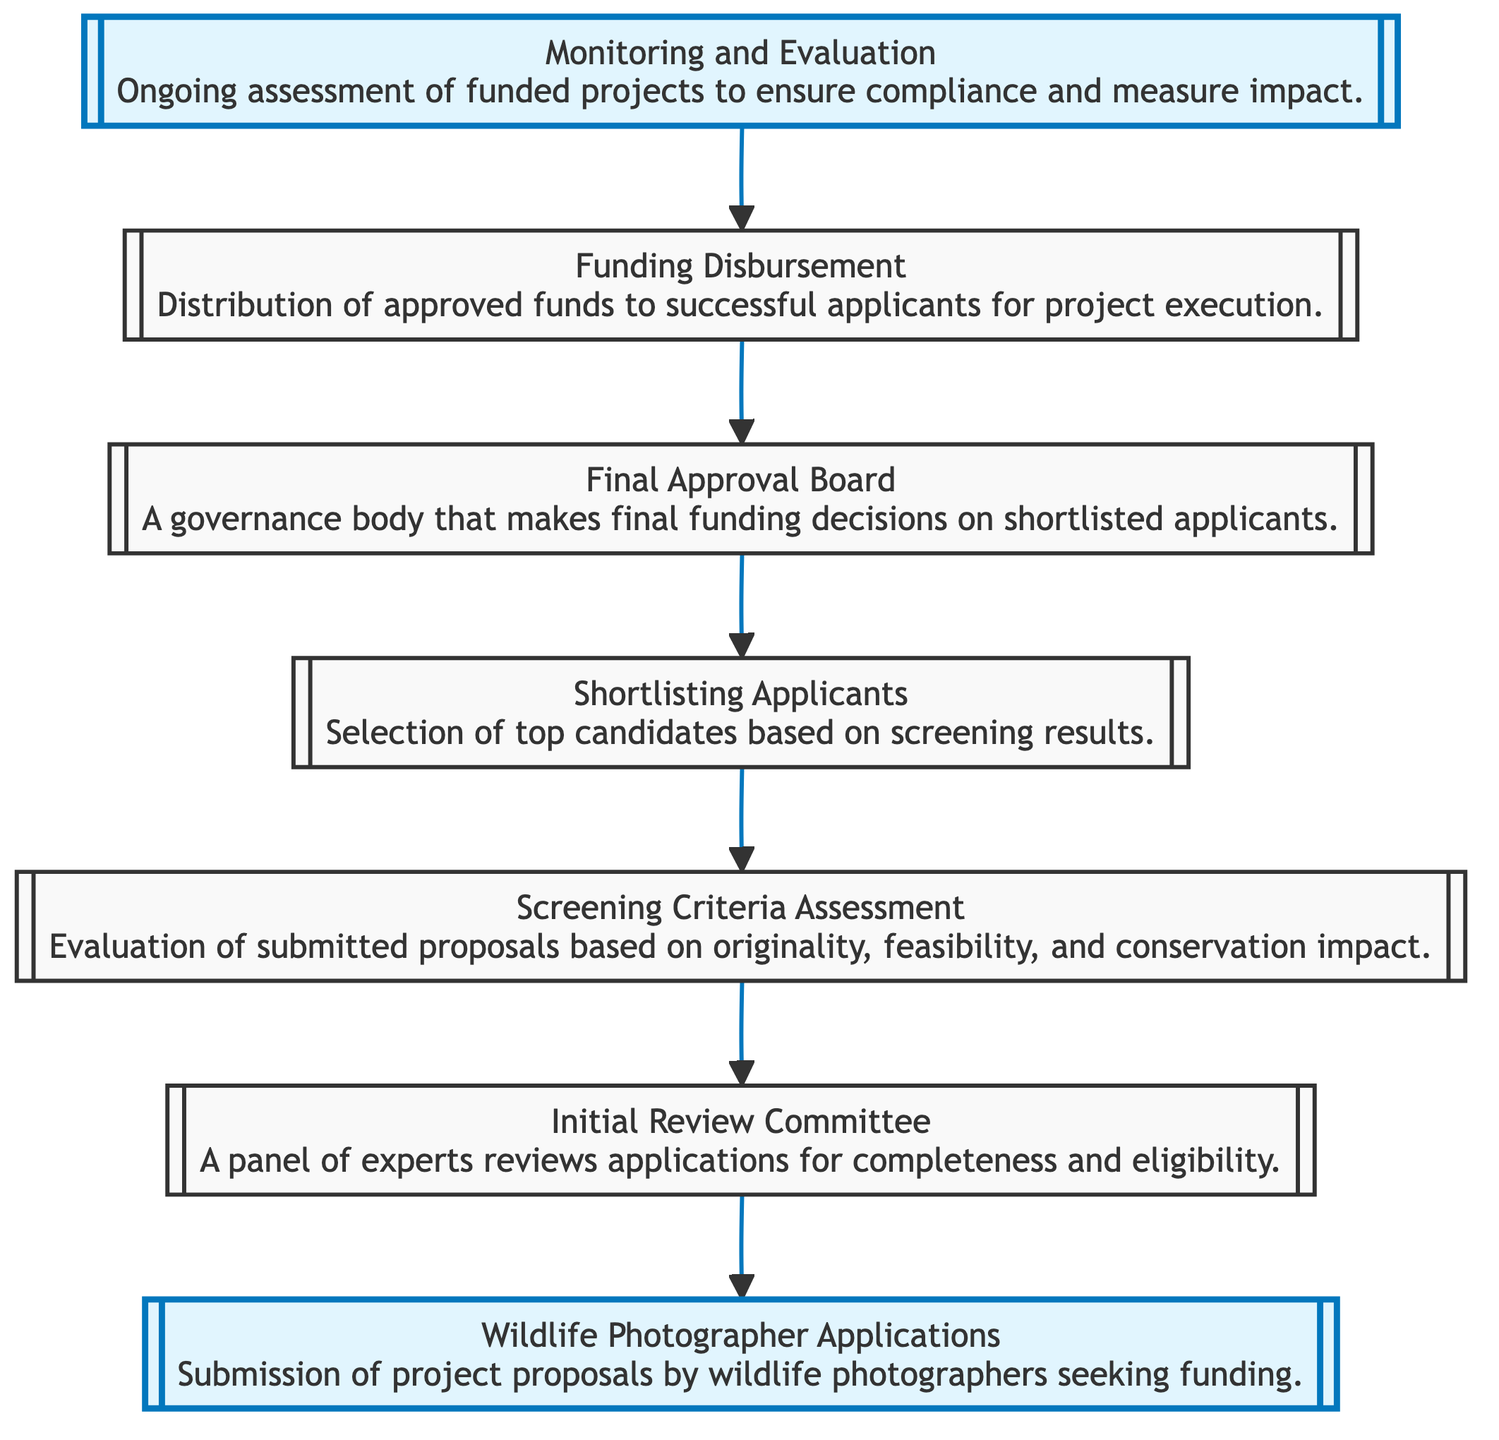What is the first step in the grant application process? The first step is the "Wildlife Photographer Applications," where project proposals are submitted by photographers seeking funding.
Answer: Wildlife Photographer Applications How many main steps are involved in this diagram? By analyzing the diagram, there are seven key steps represented, from application submission to monitoring and evaluation.
Answer: Seven What follows the "Screening Criteria Assessment"? The next step following the "Screening Criteria Assessment" is "Shortlisting Applicants," where the top candidates are selected based on screening results.
Answer: Shortlisting Applicants Who makes the final funding decisions? The "Final Approval Board" is the body responsible for making the final funding decisions on shortlisted applicants.
Answer: Final Approval Board What is the last step in the process? The final step is "Monitoring and Evaluation," which involves ongoing assessment of funded projects to ensure compliance and measure impact.
Answer: Monitoring and Evaluation Which step involves a panel of experts? The "Initial Review Committee" is where a panel of experts reviews applications for completeness and eligibility.
Answer: Initial Review Committee What criteria are used during the "Screening Criteria Assessment"? The assessment involves evaluating proposals based on originality, feasibility, and conservation impact.
Answer: Originality, feasibility, conservation impact What is the relationship between "Funding Disbursement" and "Monitoring and Evaluation"? "Funding Disbursement" follows the "Final Approval Board," and is then assessed through "Monitoring and Evaluation," creating a sequential relationship.
Answer: Sequential relationship What do successful applicants receive after approval? Successful applicants receive approved funds for project execution after the funding is disbursed.
Answer: Approved funds 